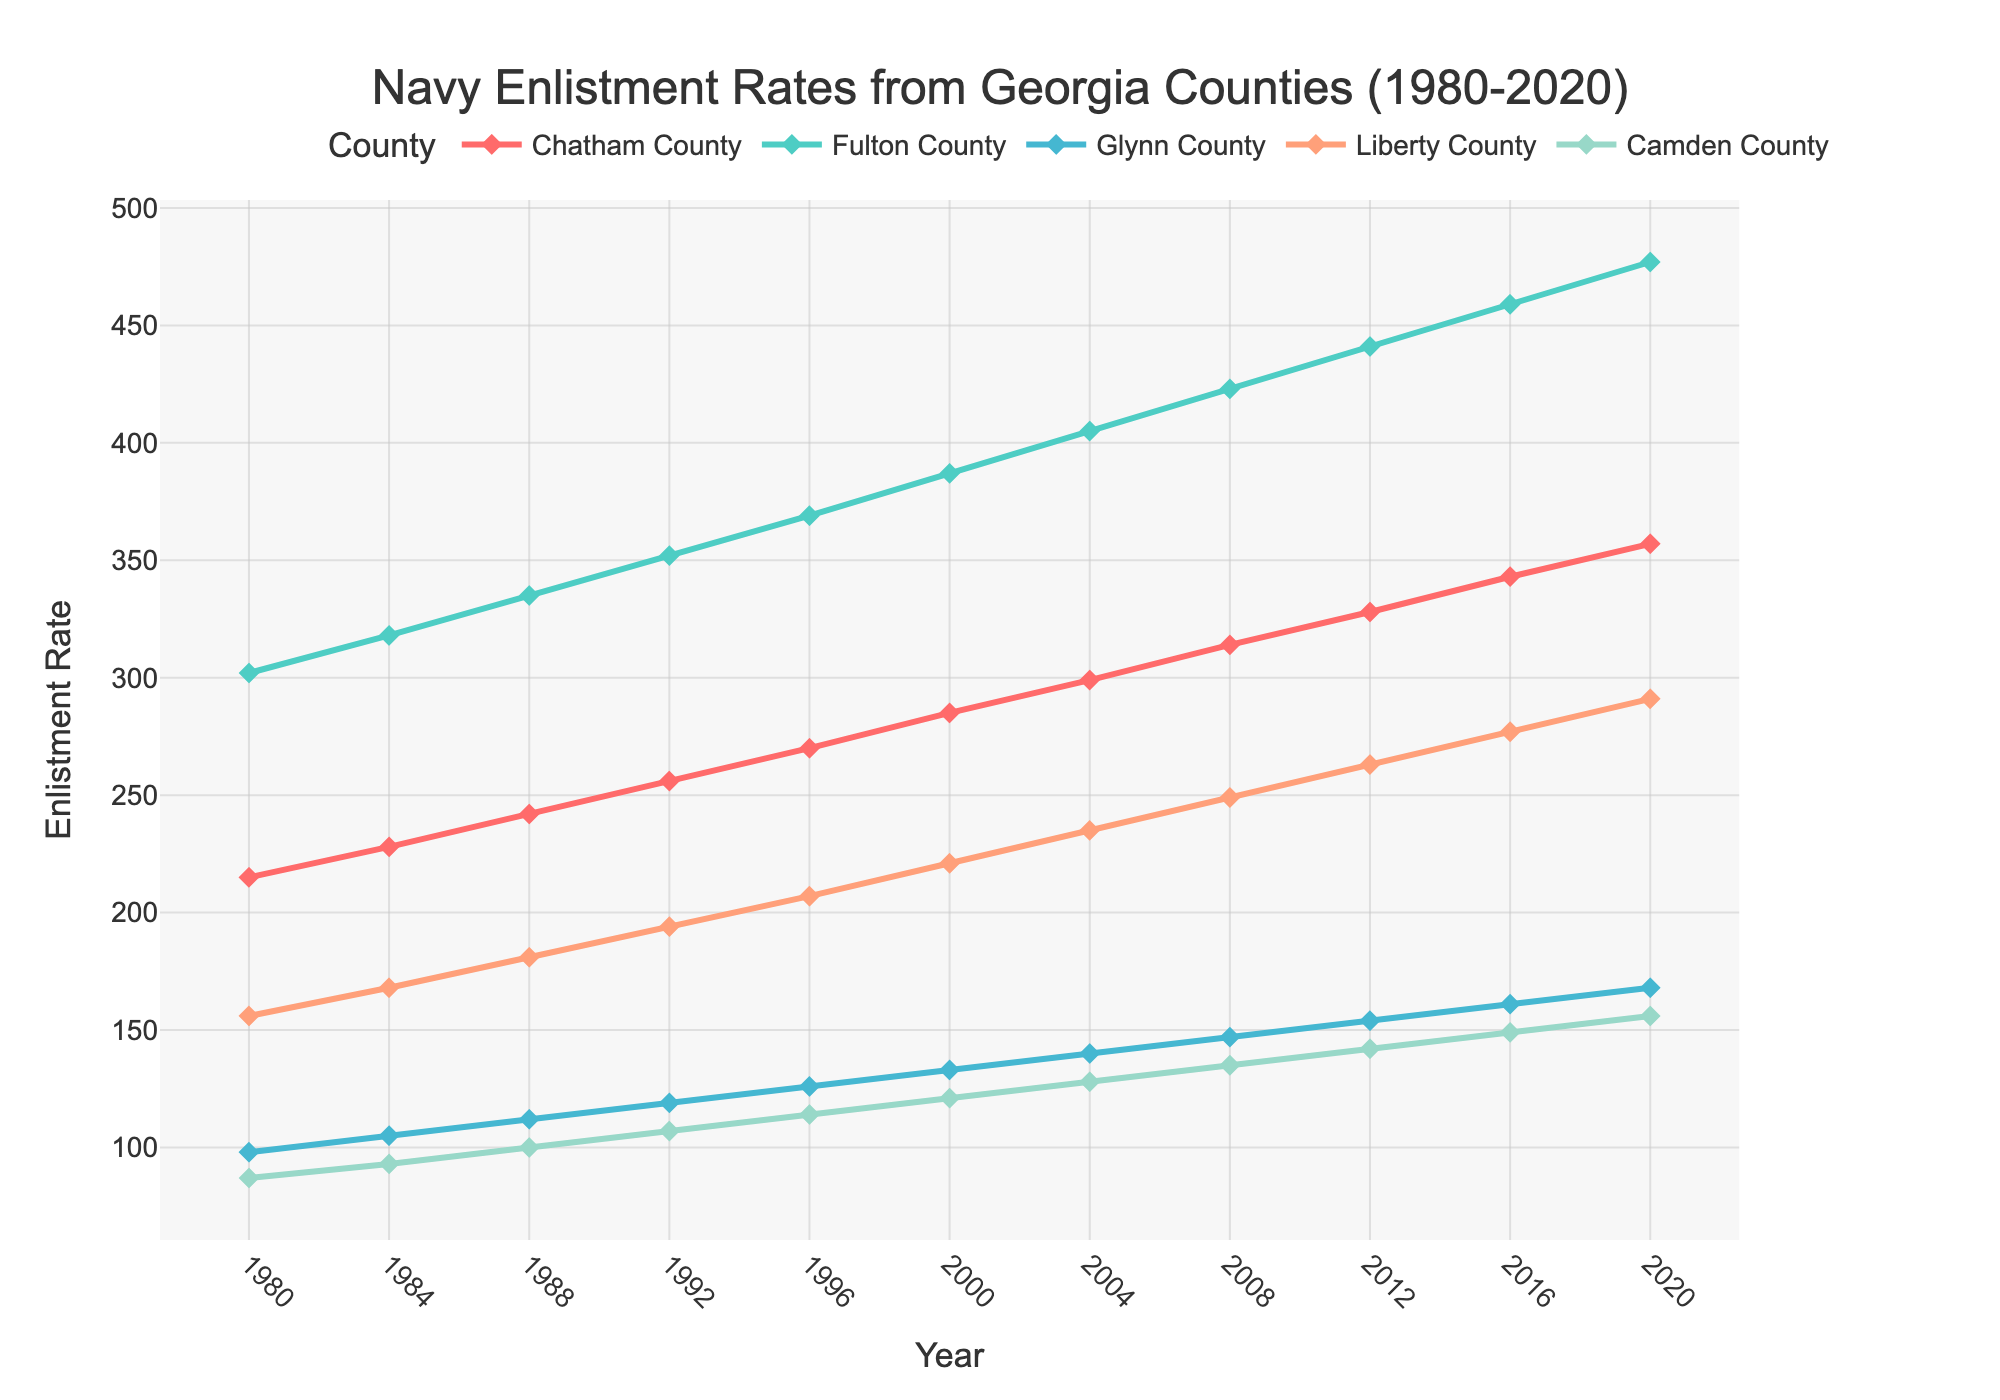What's the overall trend in the enlistment rates for Chatham County from 1980 to 2020? The enlistment rates for Chatham County show a steady upward trend from 1980 to 2020. Each year, the enlistment rate increases consistently.
Answer: Upward trend Which county had the highest enlistment rate in 2020? By observing the plot, the line corresponding to Fulton County is the highest in 2020, indicating that Fulton County had the highest enlistment rate that year.
Answer: Fulton County How did the enlistment rate for Liberty County change between 2004 and 2008? In 2004, the enlistment rate for Liberty County was 235, and in 2008, it was 249. Subtracting these values (249 - 235) shows an increase of 14.
Answer: Increased by 14 Compare the enlistment rates in 1992 and 2020 for Glynn County. What is the difference? The enlistment rate for Glynn County in 1992 was 119, and in 2020, it was 168. The difference is 168 - 119 = 49.
Answer: 49 Which county has the lowest enlistment rate in 2012? By looking at the data points for 2012, Camden County has the lowest enlistment rate among the counties plotted.
Answer: Camden County What is the average enlistment rate for Camden County over the entire period? To find the average enlistment rate, sum all enlistment rates for Camden County: 87 + 93 + 100 + 107 + 114 + 121 + 128 + 135 + 142 + 149 + 156 = 1332. Divide by the number of years (11) to get 1332 / 11 = 121.1.
Answer: 121.1 Which year shows the greatest increase in enlistment rate for Fulton County compared to the previous year? By calculating the year-to-year differences for Fulton County, the greatest increase is between 1984 and 1988 where the enlistment rate increased from 318 to 335, an increase of 17.
Answer: 1988 Of the five counties, which one had the second-highest enlistment rate in 1996? By reviewing the data for 1996, the enlistment rates are Chatham (270), Fulton (369), Glynn (126), Liberty (207), and Camden (114). Liberty County has the second-highest rate.
Answer: Liberty County Find the total enlistment rate for Chatham and Camden counties combined in 2020. The enlistment rate for Chatham County in 2020 is 357 and for Camden County is 156. Their combined rate is 357 + 156 = 513.
Answer: 513 What is the median enlistment rate for Glynn County over the last four decades? The enlistment rates for Glynn County in ascending order are: 98, 105, 112, 119, 126, 133, 140, 147, 154, 161, 168. The median value, being the middle one, is 133.
Answer: 133 